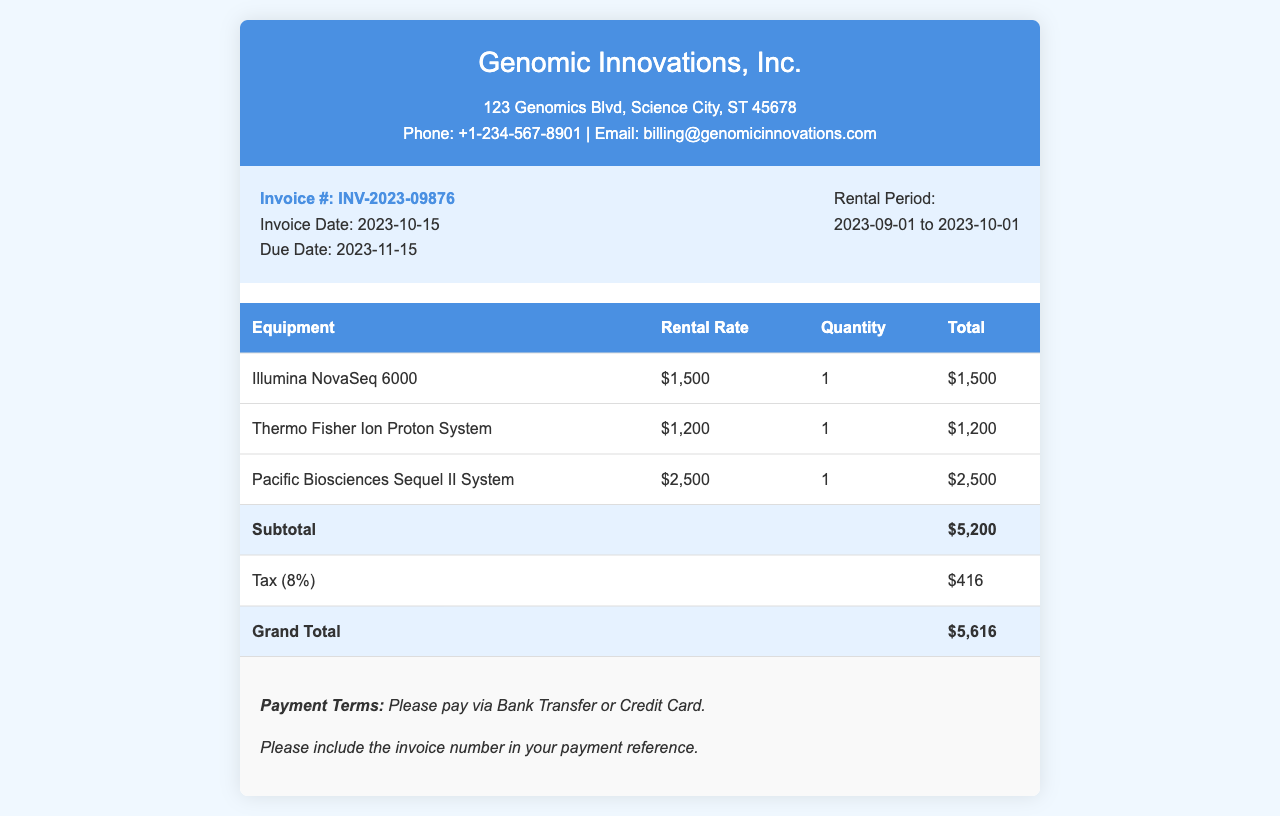What is the invoice number? The invoice number is clearly stated in the document under "Invoice #:".
Answer: INV-2023-09876 What is the total rental cost? The total rental cost is listed as the "Grand Total" in the table of the document.
Answer: $5,616 What is the rental period? The rental period is specified in the invoice details section of the document.
Answer: 2023-09-01 to 2023-10-01 What is the tax rate applied? The tax is mentioned in the document as an 8% charge on the subtotal.
Answer: 8% Which equipment has the highest rental rate? By comparing the rental rates of the listed equipment, we identify the one with the highest cost.
Answer: Pacific Biosciences Sequel II System What is the due date for payment? The due date is specified in the invoice details section of the document.
Answer: 2023-11-15 What is required in the payment reference? The payment terms specify a requirement regarding what to include in the payment reference.
Answer: Invoice number What is the subtotal before tax? The subtotal is stated clearly in the invoice table as the total before tax is added.
Answer: $5,200 